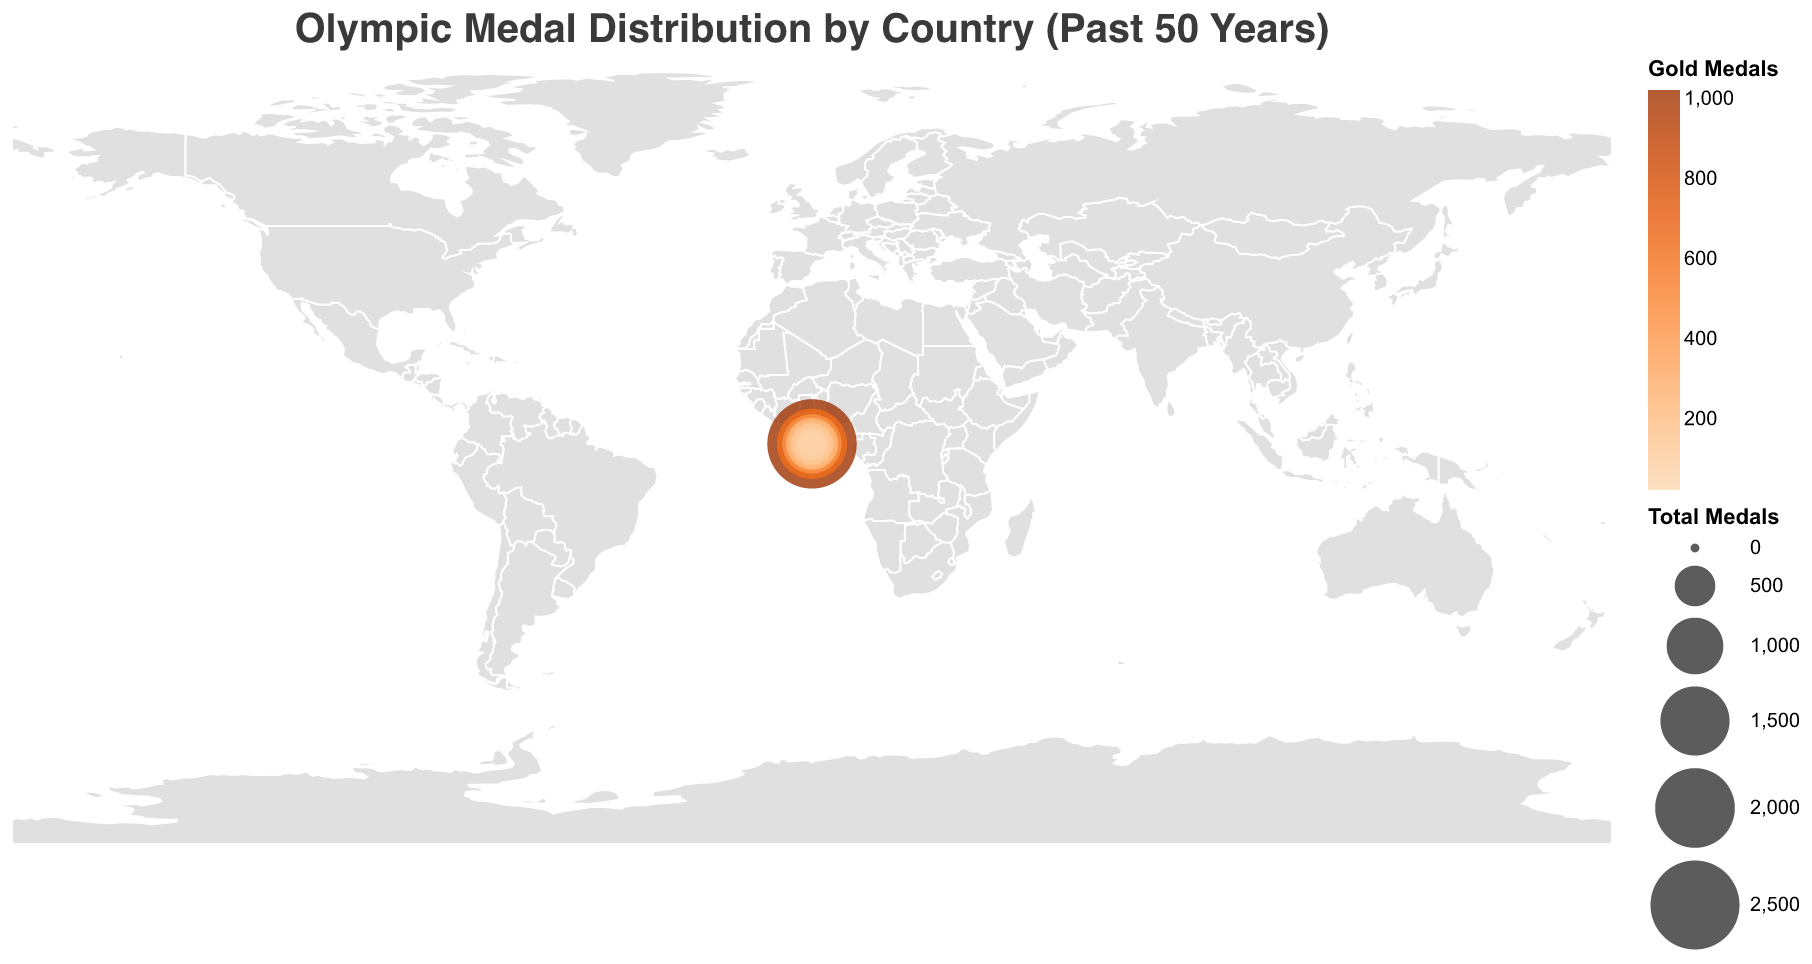What's the title of the figure? The title is usually positioned at the top of the chart and indicates the main subject. Here, it's "Olympic Medal Distribution by Country (Past 50 Years)"
Answer: Olympic Medal Distribution by Country (Past 50 Years) Which country won the most total Olympic medals? The size of the circles represents the total number of medals won. The largest circle corresponds to the United States, which has the highest number of total medals, 2522.
Answer: United States Which country has the least total Olympic medals among the listed ones? By looking at the smallest circles, we find Jamaica has the smallest circle, representing 87 total medals.
Answer: Jamaica How many more gold medals has the United States won compared to China? The United States has won 1022 gold medals, while China has won 262 gold medals. Subtracting 262 from 1022 gives 760.
Answer: 760 What is the combined total number of medals won by France and Italy? France has won 840 medals, and Italy has won 701 medals. Adding these two totals together (840 + 701) equals 1541.
Answer: 1541 Compare the number of silver medals won by the Soviet Union/Russia and Germany. Which country won more? The Soviet Union/Russia has won 490 silver medals, whereas Germany has won 350 silver medals. Therefore, the Soviet Union/Russia has won more silver medals.
Answer: Soviet Union/Russia Which two countries have the same number of total bronze medals? By comparing the number of bronze medals, the United Kingdom and Germany both have a total of 272 bronze medals each.
Answer: United Kingdom, Germany What is the geographical distribution of medals shown in the plot? The plot uses circles of varying sizes over different countries, where the size of the circle represents the total number of medals, and the color intensity represents the number of gold medals. This provides a visual understanding of medal distribution globally.
Answer: Geographical distribution uses circle size and color representation How does the number of gold medals of Australia compare to Canada? Australia's gold medals count is 167, whereas Canada's is 137. So, Australia has 30 more gold medals than Canada.
Answer: Australia Which country among the listed ones is the leading in terms of bronze medals, and how many did they win? The country with the highest bronze medals is the United States, having won 706 bronze medals, as seen by observing the tooltip information.
Answer: United States, 706 